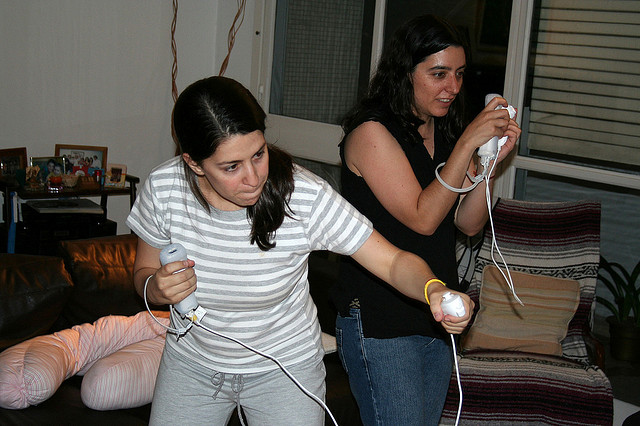<image>What type of game machines are in the background? I am not sure what type of game machines are in the background. It may be Atari, Wii, Xbox, or none. What type of game machines are in the background? I don't know what type of game machines are in the background. It can be seen 'atari', 'wii', 'x box', or 'nintendo wii'. 